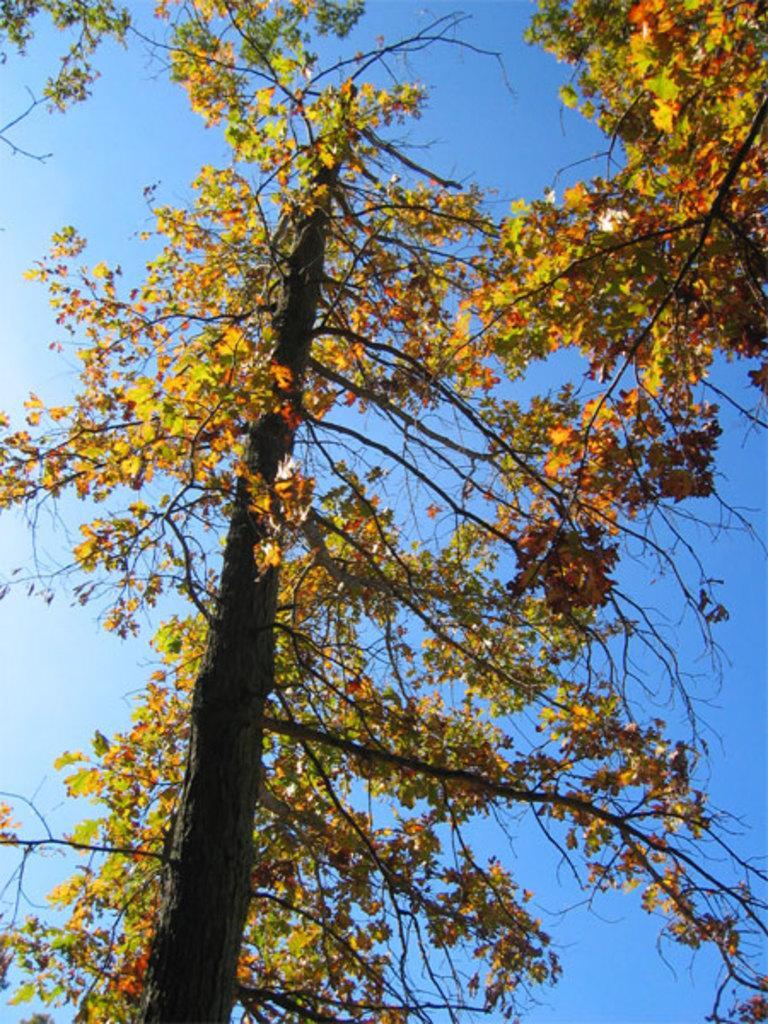Can you describe this image briefly? In this image I can see few trees in the front and in the background I can see the sky. 